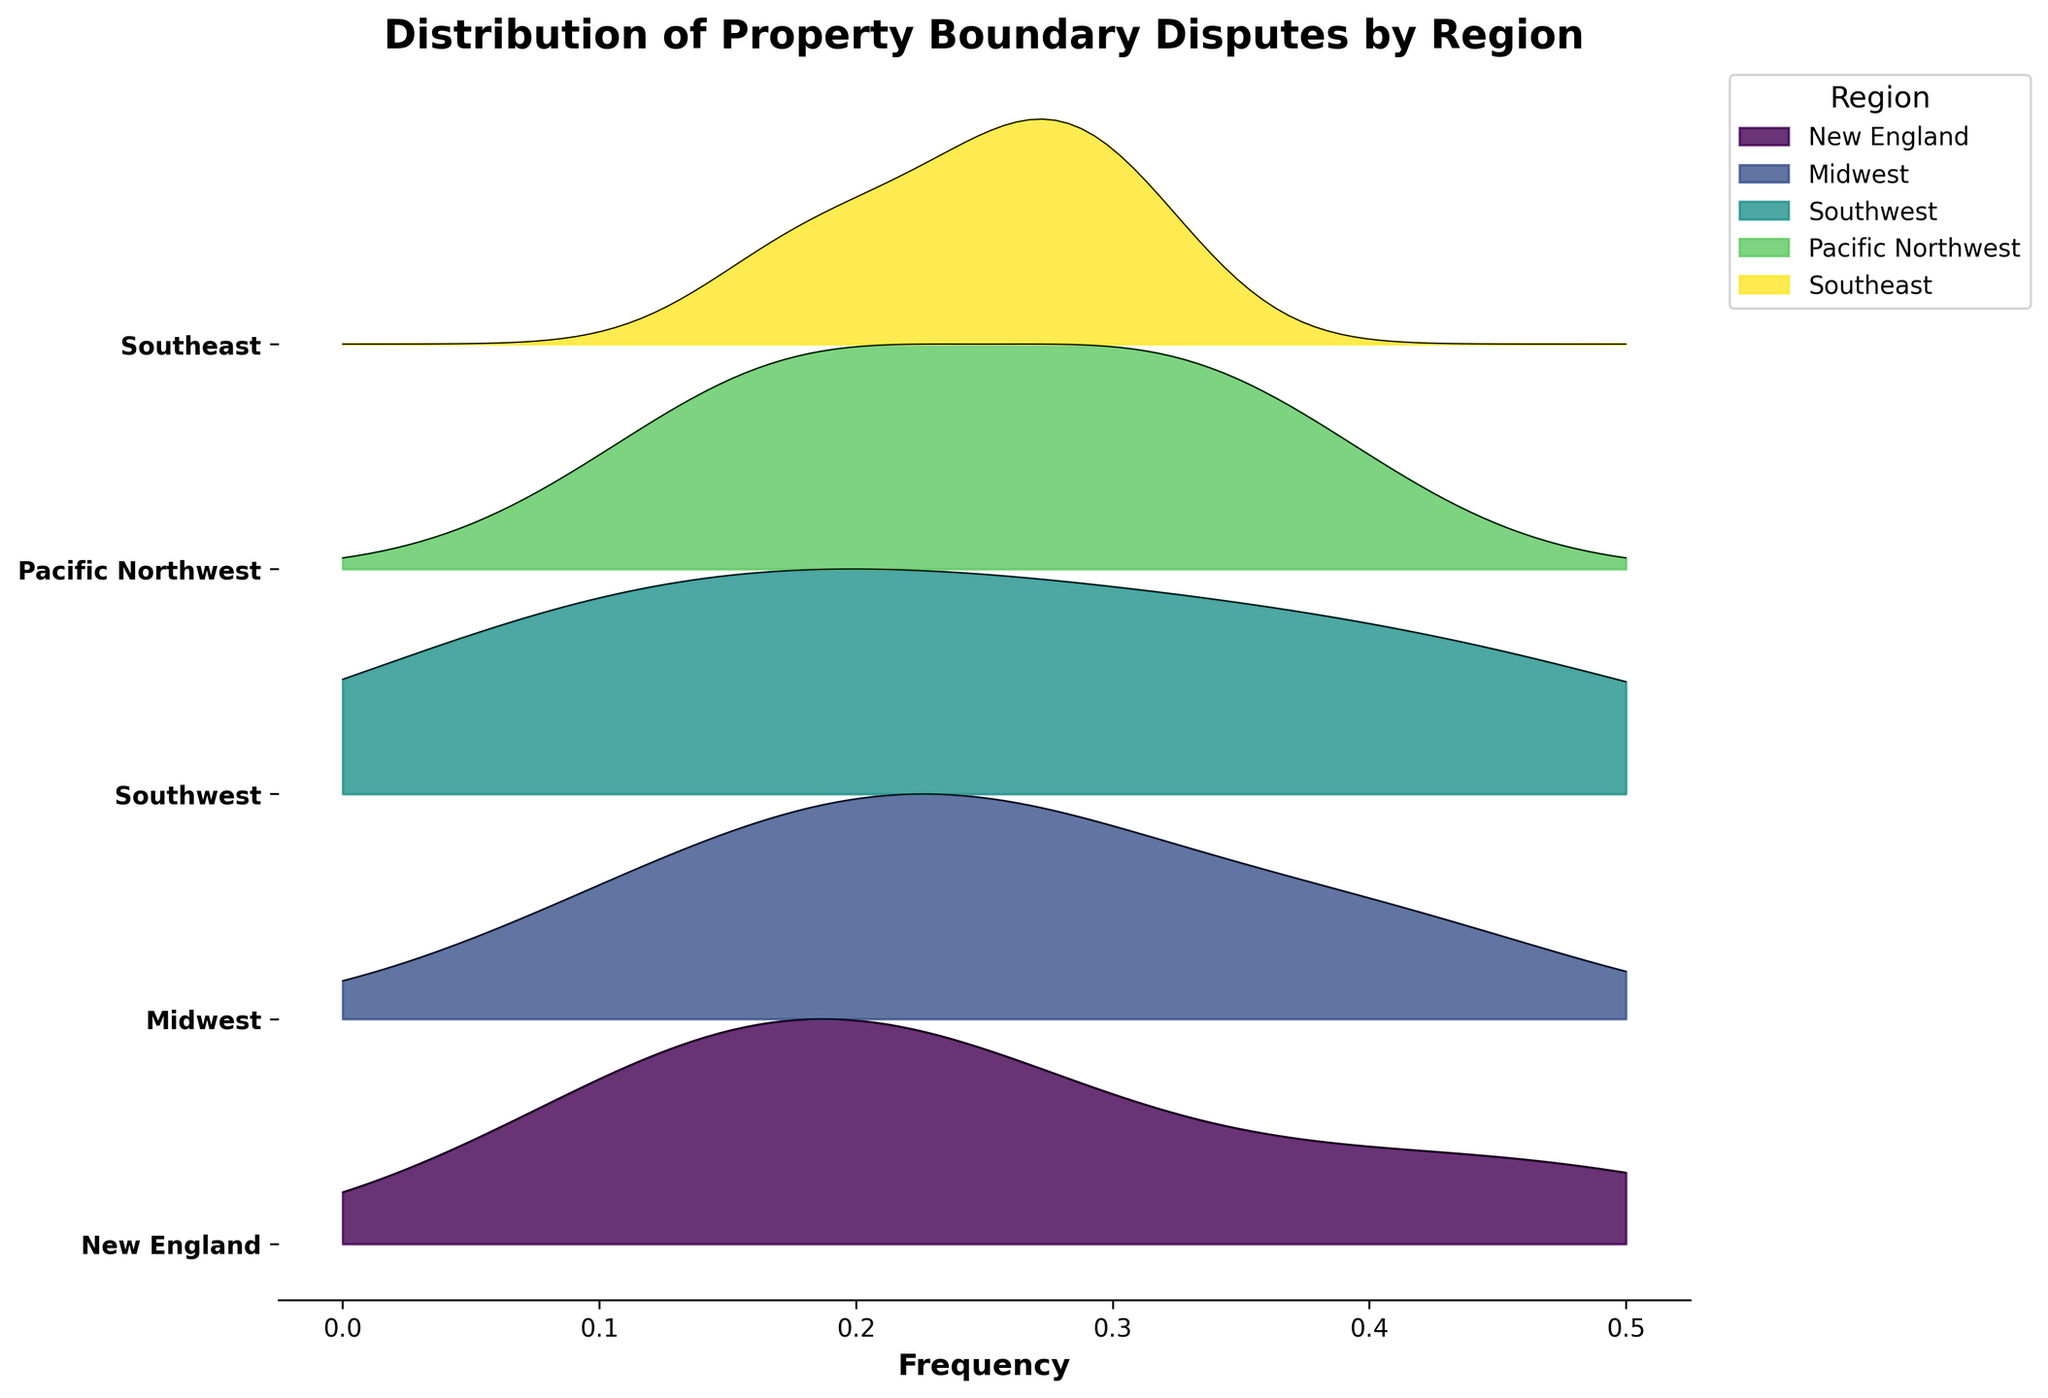What is the title of the Ridgeline plot? The title of the plot is displayed at the top and summarizes the content and purpose of the visualization.
Answer: Distribution of Property Boundary Disputes by Region What regions are represented in the Ridgeline plot? The regions are listed as labels on the y-axis, which helps identify the data distributions presented in the plot.
Answer: New England, Midwest, Southwest, Pacific Northwest, Southeast Which type of dispute has the highest frequency in the New England region? By examining the graphical representations of the New England region's frequencies, the tallest ridgeline indicates the type of dispute with the highest occurrence.
Answer: Boundary Line Disagreements What is the difference in frequency for Fence Encroachment disputes between the Midwest and Southwest regions? Locate the frequencies for Fence Encroachment in both the Midwest and Southwest regions, then compute the difference. Midwest has 0.25 and Southwest has 0.30. The difference is 0.05.
Answer: 0.05 Which region has the lowest frequency for Tree Disputes? Compare the frequencies of Tree Disputes across all regions, and identify the region with the smallest value.
Answer: Southwest How does the frequency of Easement Conflicts in the Southeast region compare to that in the New England region? Look at both regions' frequencies for Easement Conflicts and observe the values to determine which is higher. Southeast has 0.24 and New England has 0.18. Southeast has a higher frequency.
Answer: Southeast has a higher frequency Which regions have the same frequency for Boundary Line Disagreements? Check the ridgeline heights for Boundary Line Disagreements across all regions and identify the regions with matching frequencies.
Answer: New England and Southwest What's the average frequency of disputed property boundaries in the Midwest region? Sum the frequencies of all dispute types for the Midwest region, then divide by the number of dispute types. Compute (0.25 + 0.12 + 0.23 + 0.40) / 4 = 1.00 / 4 = 0.25.
Answer: 0.25 In the Ridge plot, which region exhibits the widest spread in frequencies among different dispute types? Compare the width and range of the frequency distributions for all regions. Identify which region has the greatest variation between the minimum and maximum frequencies.
Answer: Midwest What general trend can you infer about the frequency of Boundary Line Disagreements across all regions? Observe the ridgeline heights for Boundary Line Disagreements in each region and determine if there's a common pattern or trend. Noticeably high in multiple regions, suggesting they are frequently disputed.
Answer: Generally high 